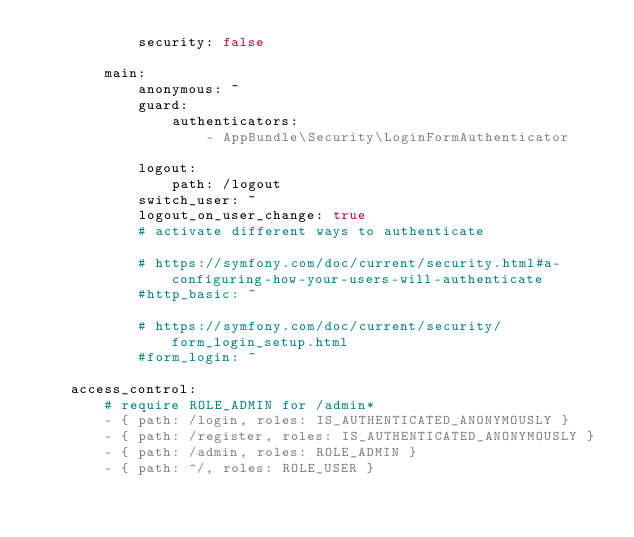<code> <loc_0><loc_0><loc_500><loc_500><_YAML_>            security: false

        main:
            anonymous: ~
            guard:
                authenticators:
                    - AppBundle\Security\LoginFormAuthenticator

            logout:
                path: /logout
            switch_user: ~
            logout_on_user_change: true
            # activate different ways to authenticate

            # https://symfony.com/doc/current/security.html#a-configuring-how-your-users-will-authenticate
            #http_basic: ~

            # https://symfony.com/doc/current/security/form_login_setup.html
            #form_login: ~

    access_control:
        # require ROLE_ADMIN for /admin*
        - { path: /login, roles: IS_AUTHENTICATED_ANONYMOUSLY }
        - { path: /register, roles: IS_AUTHENTICATED_ANONYMOUSLY }
        - { path: /admin, roles: ROLE_ADMIN }
        - { path: ^/, roles: ROLE_USER }
</code> 